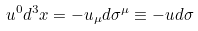<formula> <loc_0><loc_0><loc_500><loc_500>u ^ { 0 } d ^ { 3 } { x } = - u _ { \mu } d \sigma ^ { \mu } \equiv - u d \sigma</formula> 